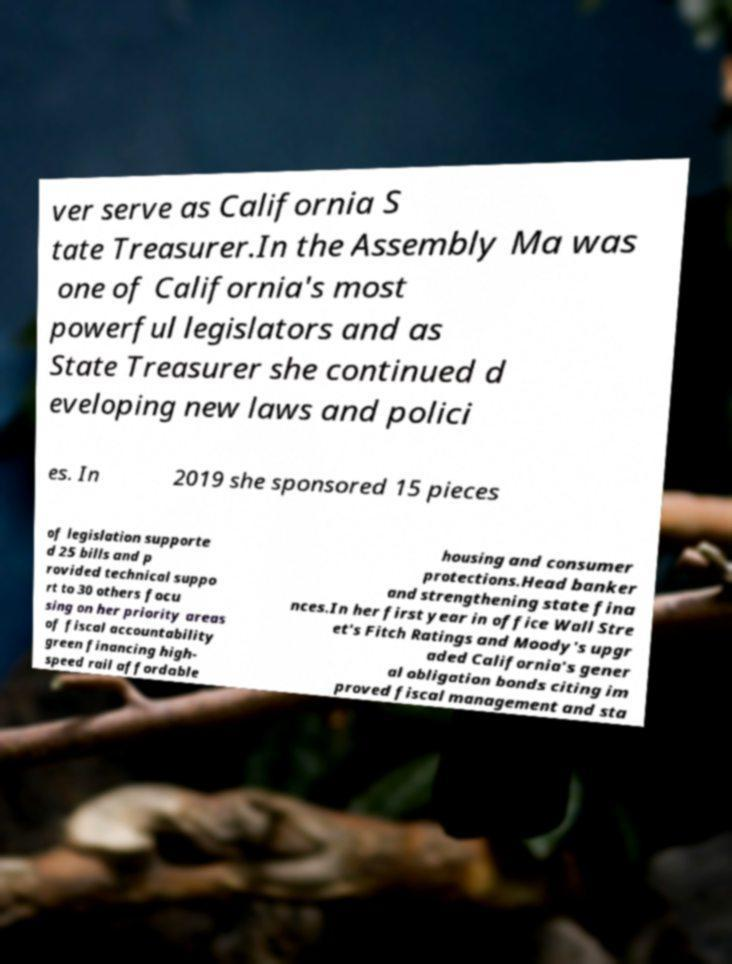What messages or text are displayed in this image? I need them in a readable, typed format. ver serve as California S tate Treasurer.In the Assembly Ma was one of California's most powerful legislators and as State Treasurer she continued d eveloping new laws and polici es. In 2019 she sponsored 15 pieces of legislation supporte d 25 bills and p rovided technical suppo rt to 30 others focu sing on her priority areas of fiscal accountability green financing high- speed rail affordable housing and consumer protections.Head banker and strengthening state fina nces.In her first year in office Wall Stre et's Fitch Ratings and Moody's upgr aded California's gener al obligation bonds citing im proved fiscal management and sta 